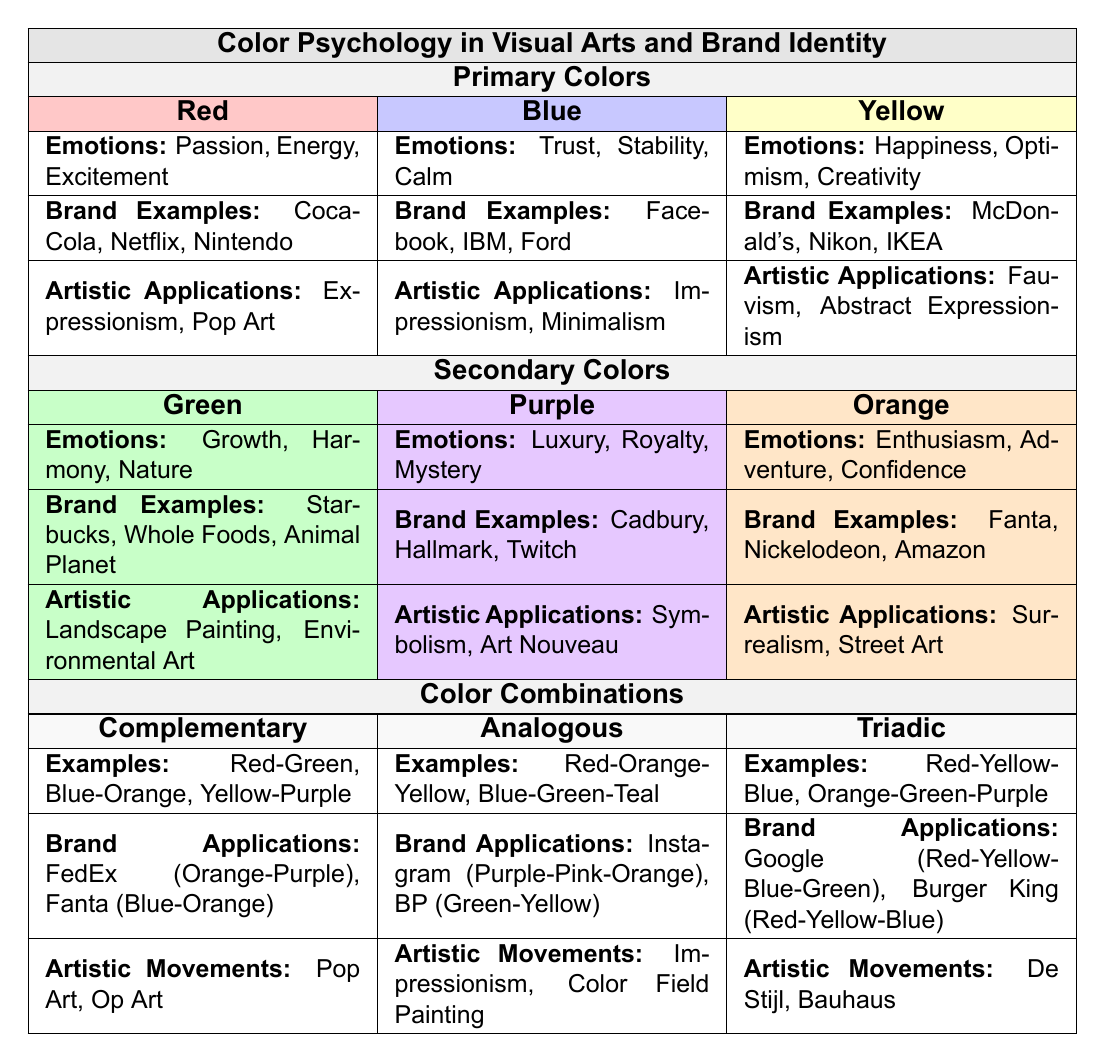What emotions are associated with the color blue? The table lists the emotions related to blue as Trust, Stability, and Calm.
Answer: Trust, Stability, Calm Which brands are associated with the color red? The brands listed under red are Coca-Cola, Netflix, and Nintendo.
Answer: Coca-Cola, Netflix, Nintendo What are some artistic applications of the color yellow? The table indicates that yellow is used in Expressionism and Abstract Expressionism.
Answer: Expressionism, Abstract Expressionism Which color has brand examples such as Starbucks and Whole Foods? The brand examples under green include Starbucks and Whole Foods, which indicates that green is the associated color.
Answer: Green True or False: The color purple evokes emotions of luxury and danger. The table shows that purple is associated with luxury, royalty, and mystery, while danger is associated with red. Thus, the statement is false.
Answer: False What are two examples of brand applications for complementary color combinations? The complementary color combinations listed in the table include FedEx (Orange-Purple) and Fanta (Blue-Orange).
Answer: FedEx (Orange-Purple), Fanta (Blue-Orange) Identify one color combination and its associated artistic movement. The table shows that the triadic color combination Red-Yellow-Blue is linked to artistic movements such as De Stijl and Bauhaus.
Answer: De Stijl, Bauhaus Which primary color is associated with enthusiasm? The primary color associated with enthusiasm is orange, as stated in the table.
Answer: Orange What is the emotional significance of the color green in Western culture? The table does not specify emotional significance for green in Western culture but lists it as a color with growth, harmony, and nature attached to it.
Answer: Growth, Harmony, Nature How many emotional associations are listed for the color yellow? The table lists three emotional associations for yellow: Happiness, Optimism, and Creativity, indicating a total of three.
Answer: 3 If we combine the brand examples for blue and yellow, what overall message might this suggest for a brand identity? Blue suggests trust and calm, while yellow suggests happiness and creativity, indicating that a brand could promote a trustworthy yet energetic image.
Answer: Trustworthy and Energetic Image 